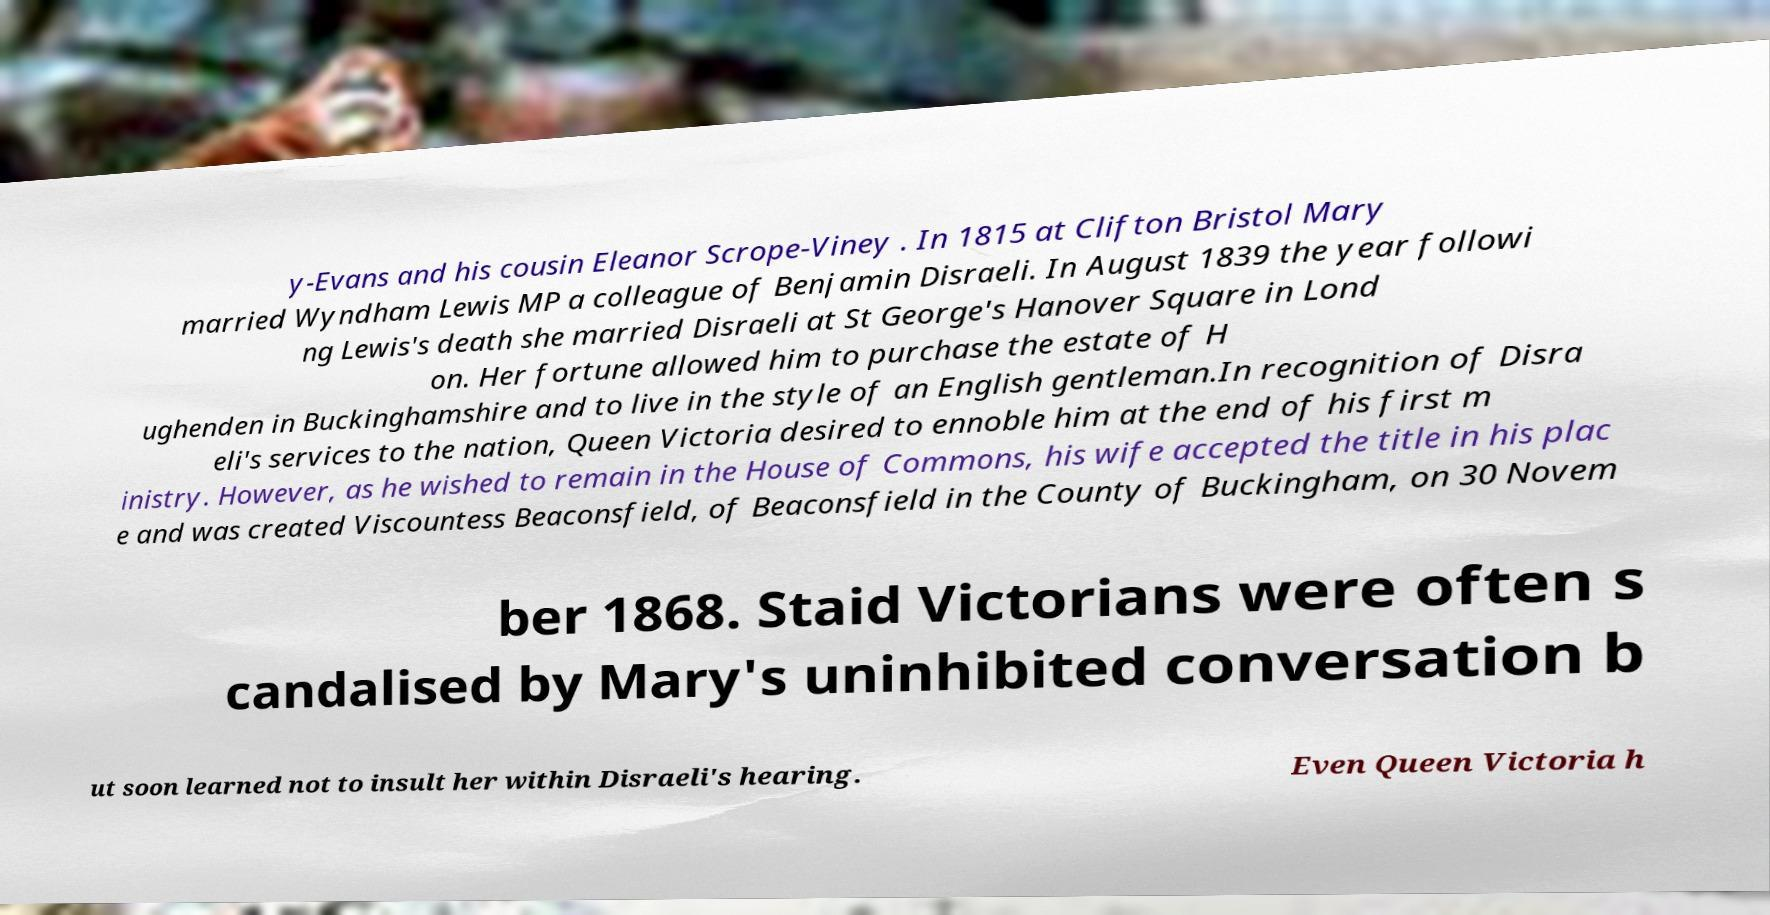Can you read and provide the text displayed in the image?This photo seems to have some interesting text. Can you extract and type it out for me? y-Evans and his cousin Eleanor Scrope-Viney . In 1815 at Clifton Bristol Mary married Wyndham Lewis MP a colleague of Benjamin Disraeli. In August 1839 the year followi ng Lewis's death she married Disraeli at St George's Hanover Square in Lond on. Her fortune allowed him to purchase the estate of H ughenden in Buckinghamshire and to live in the style of an English gentleman.In recognition of Disra eli's services to the nation, Queen Victoria desired to ennoble him at the end of his first m inistry. However, as he wished to remain in the House of Commons, his wife accepted the title in his plac e and was created Viscountess Beaconsfield, of Beaconsfield in the County of Buckingham, on 30 Novem ber 1868. Staid Victorians were often s candalised by Mary's uninhibited conversation b ut soon learned not to insult her within Disraeli's hearing. Even Queen Victoria h 